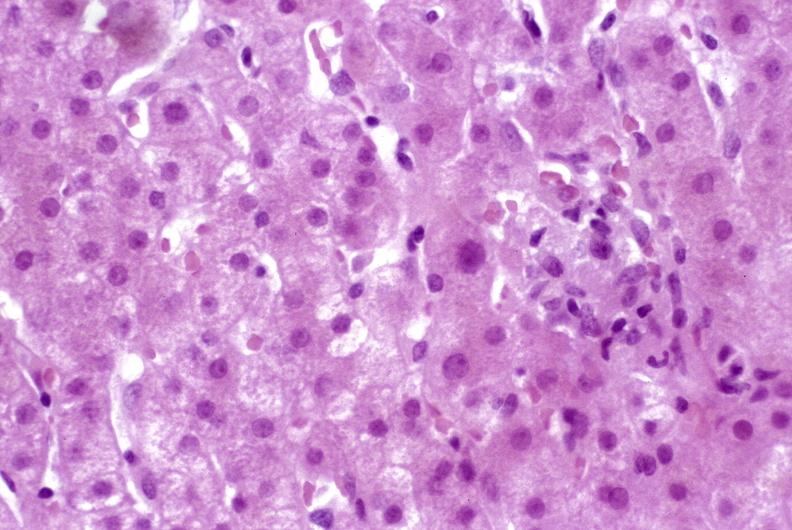does this image show granulomas?
Answer the question using a single word or phrase. Yes 